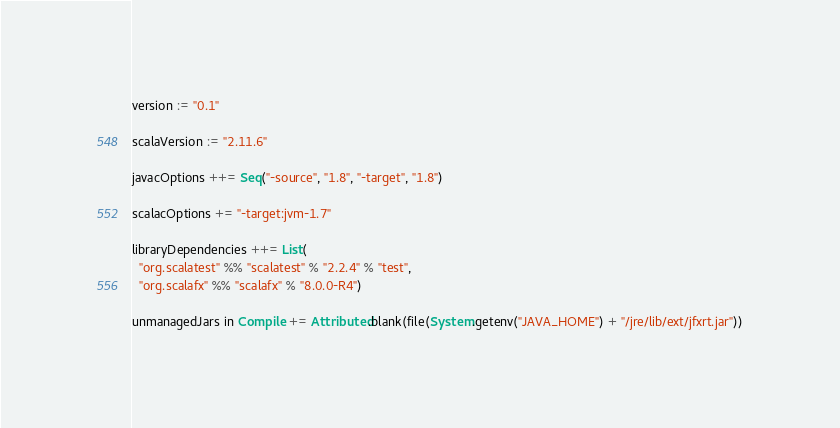<code> <loc_0><loc_0><loc_500><loc_500><_Scala_>version := "0.1"

scalaVersion := "2.11.6"

javacOptions ++= Seq("-source", "1.8", "-target", "1.8")

scalacOptions += "-target:jvm-1.7"

libraryDependencies ++= List(
  "org.scalatest" %% "scalatest" % "2.2.4" % "test",
  "org.scalafx" %% "scalafx" % "8.0.0-R4")

unmanagedJars in Compile += Attributed.blank(file(System.getenv("JAVA_HOME") + "/jre/lib/ext/jfxrt.jar"))
</code> 